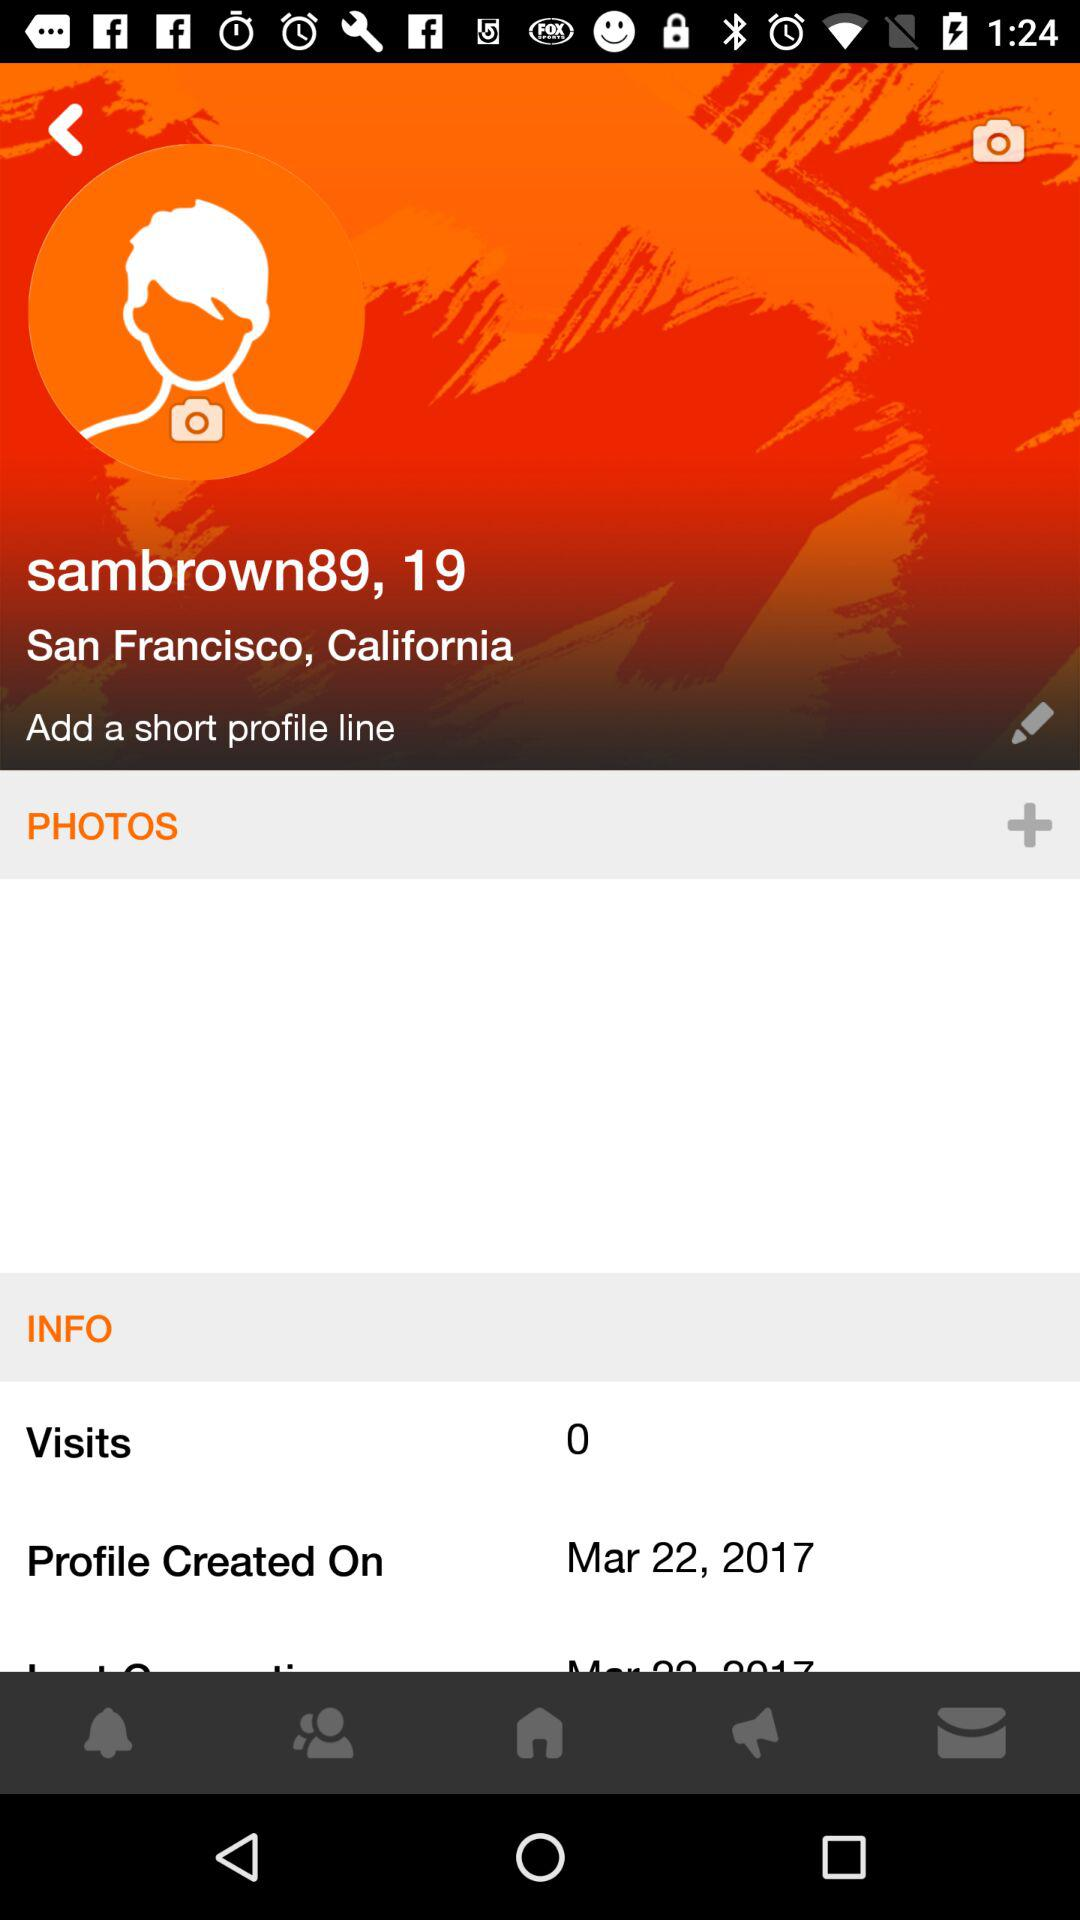How many people visited the profile? There are 0 visits on the profile. 